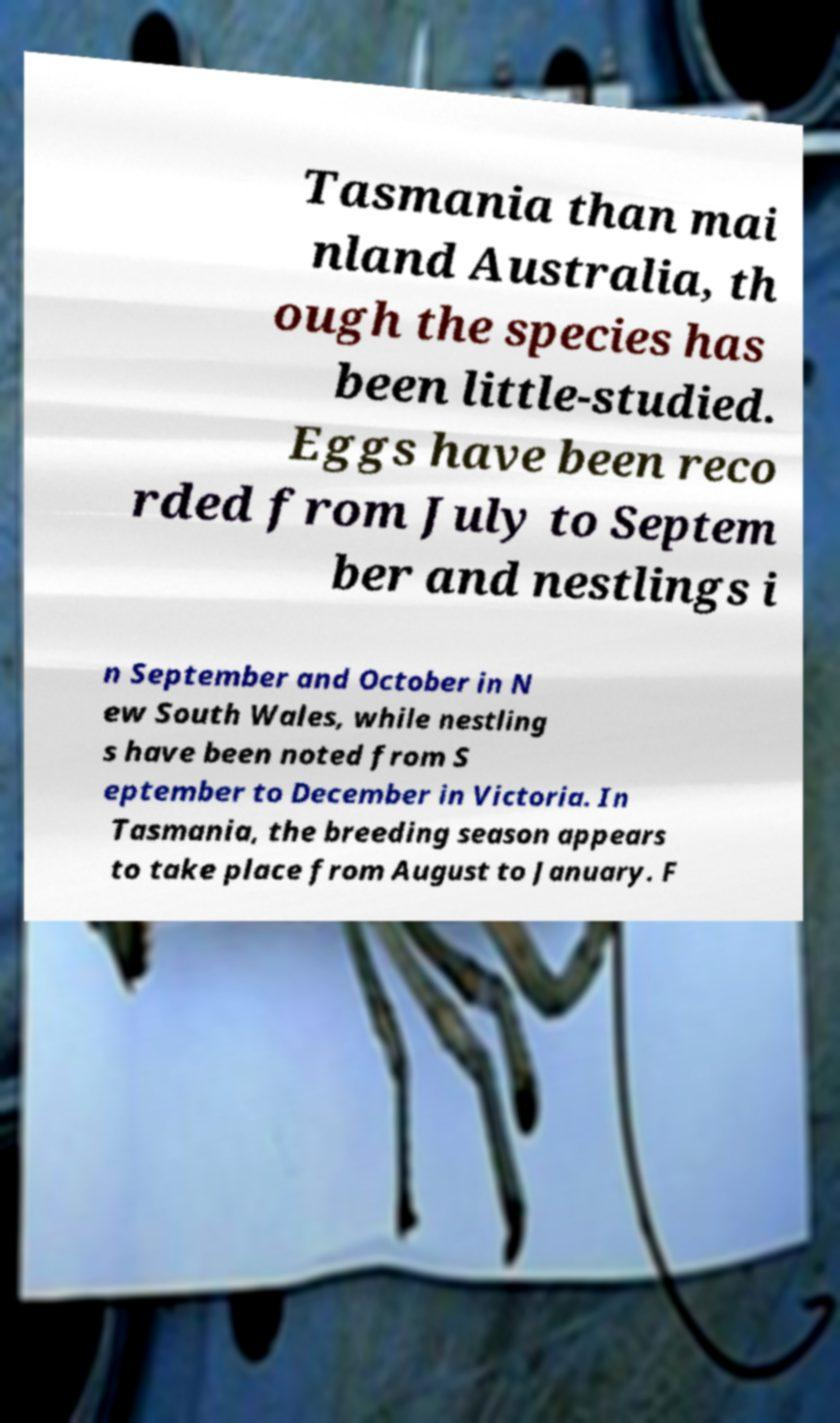Can you accurately transcribe the text from the provided image for me? Tasmania than mai nland Australia, th ough the species has been little-studied. Eggs have been reco rded from July to Septem ber and nestlings i n September and October in N ew South Wales, while nestling s have been noted from S eptember to December in Victoria. In Tasmania, the breeding season appears to take place from August to January. F 